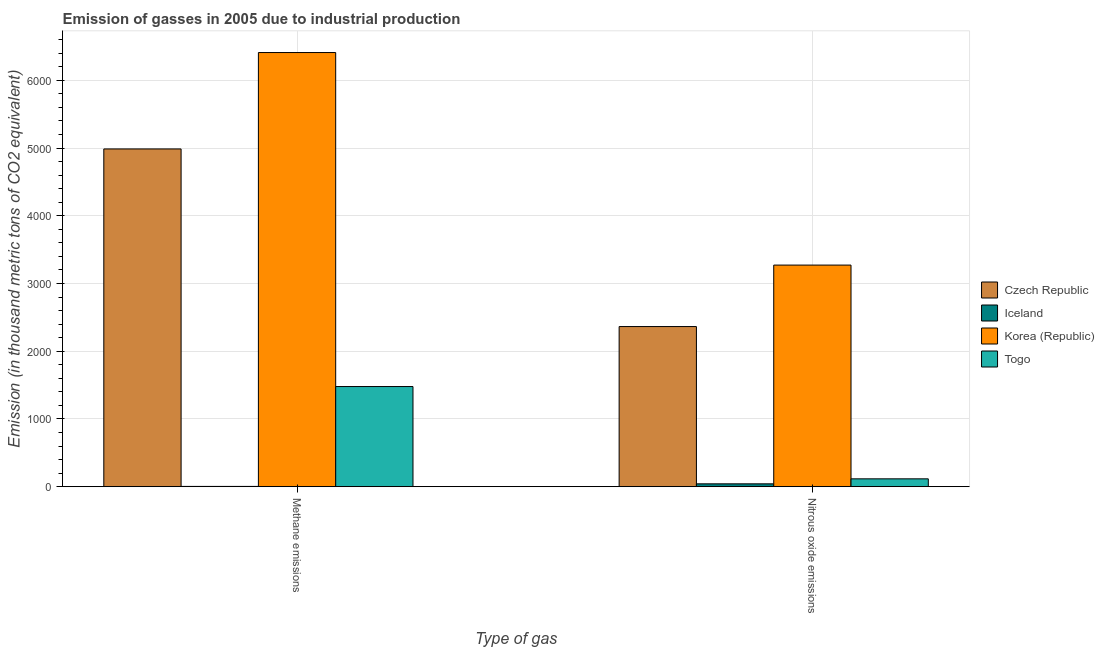How many different coloured bars are there?
Provide a short and direct response. 4. How many groups of bars are there?
Give a very brief answer. 2. What is the label of the 2nd group of bars from the left?
Your answer should be compact. Nitrous oxide emissions. What is the amount of methane emissions in Korea (Republic)?
Your answer should be very brief. 6410.4. Across all countries, what is the maximum amount of nitrous oxide emissions?
Your answer should be compact. 3272. Across all countries, what is the minimum amount of nitrous oxide emissions?
Offer a terse response. 42.1. In which country was the amount of methane emissions minimum?
Your answer should be compact. Iceland. What is the total amount of methane emissions in the graph?
Offer a very short reply. 1.29e+04. What is the difference between the amount of methane emissions in Korea (Republic) and that in Iceland?
Keep it short and to the point. 6406.4. What is the difference between the amount of nitrous oxide emissions in Iceland and the amount of methane emissions in Czech Republic?
Your answer should be very brief. -4944.8. What is the average amount of methane emissions per country?
Your answer should be very brief. 3220.02. What is the difference between the amount of methane emissions and amount of nitrous oxide emissions in Togo?
Provide a short and direct response. 1362.8. In how many countries, is the amount of nitrous oxide emissions greater than 1800 thousand metric tons?
Offer a very short reply. 2. What is the ratio of the amount of methane emissions in Korea (Republic) to that in Czech Republic?
Your response must be concise. 1.29. What does the 4th bar from the left in Methane emissions represents?
Give a very brief answer. Togo. What does the 2nd bar from the right in Methane emissions represents?
Your answer should be compact. Korea (Republic). How many bars are there?
Ensure brevity in your answer.  8. Are all the bars in the graph horizontal?
Offer a very short reply. No. What is the difference between two consecutive major ticks on the Y-axis?
Your answer should be compact. 1000. How are the legend labels stacked?
Make the answer very short. Vertical. What is the title of the graph?
Offer a very short reply. Emission of gasses in 2005 due to industrial production. Does "Pacific island small states" appear as one of the legend labels in the graph?
Your answer should be compact. No. What is the label or title of the X-axis?
Your answer should be compact. Type of gas. What is the label or title of the Y-axis?
Provide a succinct answer. Emission (in thousand metric tons of CO2 equivalent). What is the Emission (in thousand metric tons of CO2 equivalent) in Czech Republic in Methane emissions?
Ensure brevity in your answer.  4986.9. What is the Emission (in thousand metric tons of CO2 equivalent) of Korea (Republic) in Methane emissions?
Keep it short and to the point. 6410.4. What is the Emission (in thousand metric tons of CO2 equivalent) in Togo in Methane emissions?
Offer a terse response. 1478.8. What is the Emission (in thousand metric tons of CO2 equivalent) of Czech Republic in Nitrous oxide emissions?
Offer a very short reply. 2364.5. What is the Emission (in thousand metric tons of CO2 equivalent) in Iceland in Nitrous oxide emissions?
Give a very brief answer. 42.1. What is the Emission (in thousand metric tons of CO2 equivalent) in Korea (Republic) in Nitrous oxide emissions?
Your response must be concise. 3272. What is the Emission (in thousand metric tons of CO2 equivalent) in Togo in Nitrous oxide emissions?
Offer a terse response. 116. Across all Type of gas, what is the maximum Emission (in thousand metric tons of CO2 equivalent) in Czech Republic?
Provide a succinct answer. 4986.9. Across all Type of gas, what is the maximum Emission (in thousand metric tons of CO2 equivalent) in Iceland?
Offer a very short reply. 42.1. Across all Type of gas, what is the maximum Emission (in thousand metric tons of CO2 equivalent) of Korea (Republic)?
Your answer should be very brief. 6410.4. Across all Type of gas, what is the maximum Emission (in thousand metric tons of CO2 equivalent) in Togo?
Make the answer very short. 1478.8. Across all Type of gas, what is the minimum Emission (in thousand metric tons of CO2 equivalent) in Czech Republic?
Offer a very short reply. 2364.5. Across all Type of gas, what is the minimum Emission (in thousand metric tons of CO2 equivalent) of Korea (Republic)?
Your answer should be very brief. 3272. Across all Type of gas, what is the minimum Emission (in thousand metric tons of CO2 equivalent) in Togo?
Offer a terse response. 116. What is the total Emission (in thousand metric tons of CO2 equivalent) of Czech Republic in the graph?
Offer a terse response. 7351.4. What is the total Emission (in thousand metric tons of CO2 equivalent) in Iceland in the graph?
Give a very brief answer. 46.1. What is the total Emission (in thousand metric tons of CO2 equivalent) in Korea (Republic) in the graph?
Your answer should be very brief. 9682.4. What is the total Emission (in thousand metric tons of CO2 equivalent) of Togo in the graph?
Make the answer very short. 1594.8. What is the difference between the Emission (in thousand metric tons of CO2 equivalent) in Czech Republic in Methane emissions and that in Nitrous oxide emissions?
Make the answer very short. 2622.4. What is the difference between the Emission (in thousand metric tons of CO2 equivalent) in Iceland in Methane emissions and that in Nitrous oxide emissions?
Your response must be concise. -38.1. What is the difference between the Emission (in thousand metric tons of CO2 equivalent) in Korea (Republic) in Methane emissions and that in Nitrous oxide emissions?
Your answer should be compact. 3138.4. What is the difference between the Emission (in thousand metric tons of CO2 equivalent) in Togo in Methane emissions and that in Nitrous oxide emissions?
Your answer should be compact. 1362.8. What is the difference between the Emission (in thousand metric tons of CO2 equivalent) of Czech Republic in Methane emissions and the Emission (in thousand metric tons of CO2 equivalent) of Iceland in Nitrous oxide emissions?
Provide a succinct answer. 4944.8. What is the difference between the Emission (in thousand metric tons of CO2 equivalent) in Czech Republic in Methane emissions and the Emission (in thousand metric tons of CO2 equivalent) in Korea (Republic) in Nitrous oxide emissions?
Keep it short and to the point. 1714.9. What is the difference between the Emission (in thousand metric tons of CO2 equivalent) in Czech Republic in Methane emissions and the Emission (in thousand metric tons of CO2 equivalent) in Togo in Nitrous oxide emissions?
Offer a terse response. 4870.9. What is the difference between the Emission (in thousand metric tons of CO2 equivalent) of Iceland in Methane emissions and the Emission (in thousand metric tons of CO2 equivalent) of Korea (Republic) in Nitrous oxide emissions?
Provide a short and direct response. -3268. What is the difference between the Emission (in thousand metric tons of CO2 equivalent) of Iceland in Methane emissions and the Emission (in thousand metric tons of CO2 equivalent) of Togo in Nitrous oxide emissions?
Keep it short and to the point. -112. What is the difference between the Emission (in thousand metric tons of CO2 equivalent) in Korea (Republic) in Methane emissions and the Emission (in thousand metric tons of CO2 equivalent) in Togo in Nitrous oxide emissions?
Provide a succinct answer. 6294.4. What is the average Emission (in thousand metric tons of CO2 equivalent) of Czech Republic per Type of gas?
Keep it short and to the point. 3675.7. What is the average Emission (in thousand metric tons of CO2 equivalent) of Iceland per Type of gas?
Your response must be concise. 23.05. What is the average Emission (in thousand metric tons of CO2 equivalent) in Korea (Republic) per Type of gas?
Provide a short and direct response. 4841.2. What is the average Emission (in thousand metric tons of CO2 equivalent) of Togo per Type of gas?
Your answer should be compact. 797.4. What is the difference between the Emission (in thousand metric tons of CO2 equivalent) in Czech Republic and Emission (in thousand metric tons of CO2 equivalent) in Iceland in Methane emissions?
Make the answer very short. 4982.9. What is the difference between the Emission (in thousand metric tons of CO2 equivalent) of Czech Republic and Emission (in thousand metric tons of CO2 equivalent) of Korea (Republic) in Methane emissions?
Give a very brief answer. -1423.5. What is the difference between the Emission (in thousand metric tons of CO2 equivalent) of Czech Republic and Emission (in thousand metric tons of CO2 equivalent) of Togo in Methane emissions?
Provide a short and direct response. 3508.1. What is the difference between the Emission (in thousand metric tons of CO2 equivalent) in Iceland and Emission (in thousand metric tons of CO2 equivalent) in Korea (Republic) in Methane emissions?
Your answer should be compact. -6406.4. What is the difference between the Emission (in thousand metric tons of CO2 equivalent) in Iceland and Emission (in thousand metric tons of CO2 equivalent) in Togo in Methane emissions?
Keep it short and to the point. -1474.8. What is the difference between the Emission (in thousand metric tons of CO2 equivalent) in Korea (Republic) and Emission (in thousand metric tons of CO2 equivalent) in Togo in Methane emissions?
Provide a succinct answer. 4931.6. What is the difference between the Emission (in thousand metric tons of CO2 equivalent) of Czech Republic and Emission (in thousand metric tons of CO2 equivalent) of Iceland in Nitrous oxide emissions?
Give a very brief answer. 2322.4. What is the difference between the Emission (in thousand metric tons of CO2 equivalent) in Czech Republic and Emission (in thousand metric tons of CO2 equivalent) in Korea (Republic) in Nitrous oxide emissions?
Your answer should be very brief. -907.5. What is the difference between the Emission (in thousand metric tons of CO2 equivalent) of Czech Republic and Emission (in thousand metric tons of CO2 equivalent) of Togo in Nitrous oxide emissions?
Offer a very short reply. 2248.5. What is the difference between the Emission (in thousand metric tons of CO2 equivalent) in Iceland and Emission (in thousand metric tons of CO2 equivalent) in Korea (Republic) in Nitrous oxide emissions?
Make the answer very short. -3229.9. What is the difference between the Emission (in thousand metric tons of CO2 equivalent) of Iceland and Emission (in thousand metric tons of CO2 equivalent) of Togo in Nitrous oxide emissions?
Offer a terse response. -73.9. What is the difference between the Emission (in thousand metric tons of CO2 equivalent) of Korea (Republic) and Emission (in thousand metric tons of CO2 equivalent) of Togo in Nitrous oxide emissions?
Ensure brevity in your answer.  3156. What is the ratio of the Emission (in thousand metric tons of CO2 equivalent) in Czech Republic in Methane emissions to that in Nitrous oxide emissions?
Ensure brevity in your answer.  2.11. What is the ratio of the Emission (in thousand metric tons of CO2 equivalent) in Iceland in Methane emissions to that in Nitrous oxide emissions?
Keep it short and to the point. 0.1. What is the ratio of the Emission (in thousand metric tons of CO2 equivalent) of Korea (Republic) in Methane emissions to that in Nitrous oxide emissions?
Your answer should be very brief. 1.96. What is the ratio of the Emission (in thousand metric tons of CO2 equivalent) of Togo in Methane emissions to that in Nitrous oxide emissions?
Offer a very short reply. 12.75. What is the difference between the highest and the second highest Emission (in thousand metric tons of CO2 equivalent) of Czech Republic?
Make the answer very short. 2622.4. What is the difference between the highest and the second highest Emission (in thousand metric tons of CO2 equivalent) in Iceland?
Your answer should be very brief. 38.1. What is the difference between the highest and the second highest Emission (in thousand metric tons of CO2 equivalent) of Korea (Republic)?
Ensure brevity in your answer.  3138.4. What is the difference between the highest and the second highest Emission (in thousand metric tons of CO2 equivalent) of Togo?
Ensure brevity in your answer.  1362.8. What is the difference between the highest and the lowest Emission (in thousand metric tons of CO2 equivalent) in Czech Republic?
Give a very brief answer. 2622.4. What is the difference between the highest and the lowest Emission (in thousand metric tons of CO2 equivalent) of Iceland?
Your response must be concise. 38.1. What is the difference between the highest and the lowest Emission (in thousand metric tons of CO2 equivalent) in Korea (Republic)?
Offer a very short reply. 3138.4. What is the difference between the highest and the lowest Emission (in thousand metric tons of CO2 equivalent) of Togo?
Ensure brevity in your answer.  1362.8. 